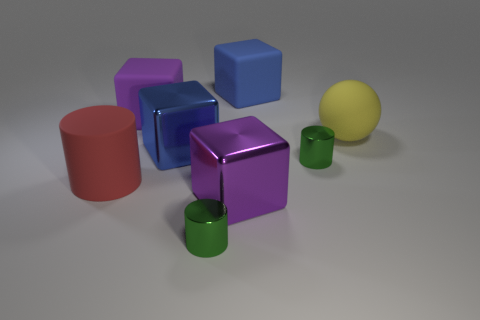There is a big metallic thing that is in front of the large red cylinder; what is its shape?
Keep it short and to the point. Cube. There is a purple metal thing that is the same size as the ball; what is its shape?
Keep it short and to the point. Cube. The big matte block on the right side of the rubber block that is on the left side of the blue object on the right side of the large blue shiny block is what color?
Keep it short and to the point. Blue. Is the yellow object the same shape as the big red rubber thing?
Ensure brevity in your answer.  No. Are there an equal number of small green shiny cylinders that are behind the yellow rubber sphere and large red matte things?
Offer a terse response. No. Does the matte block that is on the left side of the purple metallic cube have the same size as the red rubber thing that is to the left of the big blue rubber object?
Your answer should be very brief. Yes. What number of objects are things that are behind the large rubber ball or rubber cubes to the right of the blue shiny cube?
Offer a very short reply. 2. Is there anything else that is the same shape as the blue metallic thing?
Your answer should be very brief. Yes. There is a matte thing in front of the yellow rubber object; does it have the same color as the big metal object in front of the big blue shiny object?
Ensure brevity in your answer.  No. What number of matte objects are purple objects or big red cylinders?
Your answer should be compact. 2. 